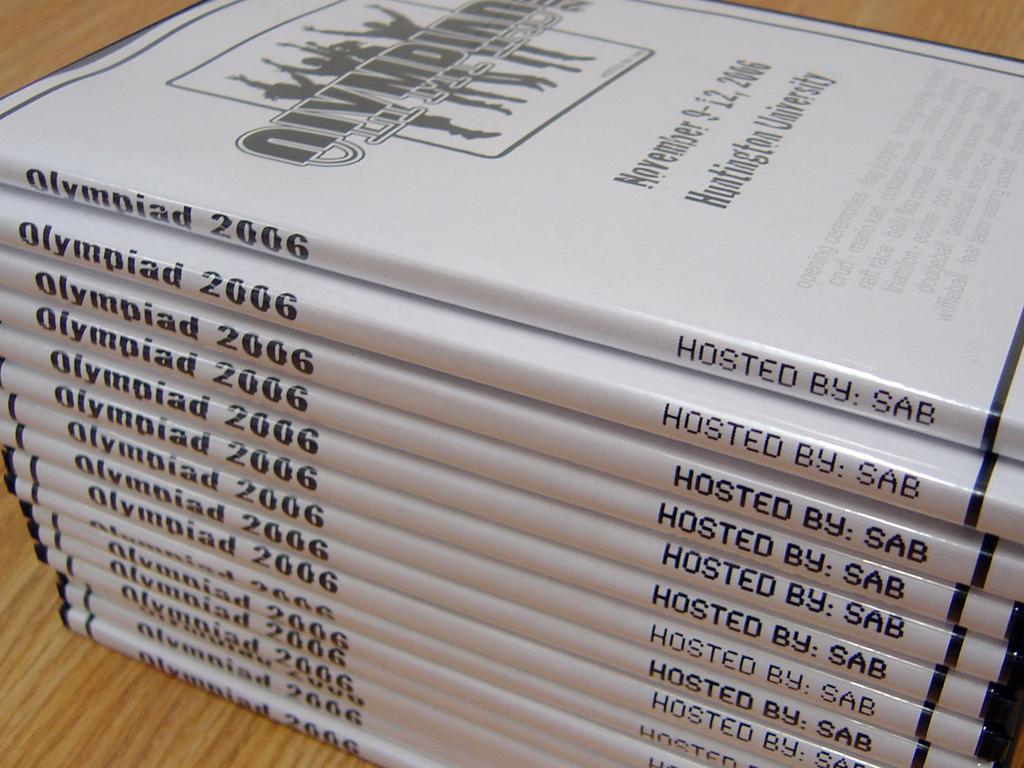What year was this?
Provide a succinct answer. 2006. 